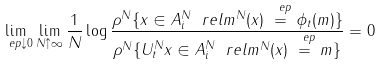Convert formula to latex. <formula><loc_0><loc_0><loc_500><loc_500>\lim _ { \ e p \downarrow 0 } \lim _ { N \uparrow \infty } \frac { 1 } { N } \log \frac { \rho ^ { N } \{ x \in A ^ { N } _ { i } \ r e l m ^ { N } ( x ) \stackrel { \ e p } { = } \phi _ { t } ( m ) \} } { \rho ^ { N } \{ U ^ { N } _ { t } x \in A ^ { N } _ { i } \ r e l m ^ { N } ( x ) \stackrel { \ e p } { = } m \} } = 0</formula> 